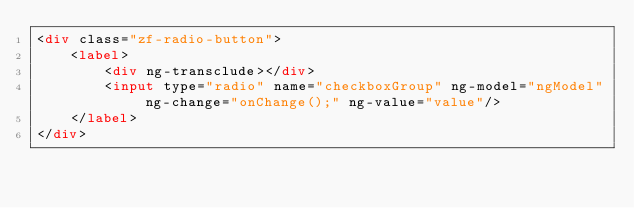Convert code to text. <code><loc_0><loc_0><loc_500><loc_500><_HTML_><div class="zf-radio-button">
    <label>
        <div ng-transclude></div>
        <input type="radio" name="checkboxGroup" ng-model="ngModel" ng-change="onChange();" ng-value="value"/>
    </label>
</div>
</code> 